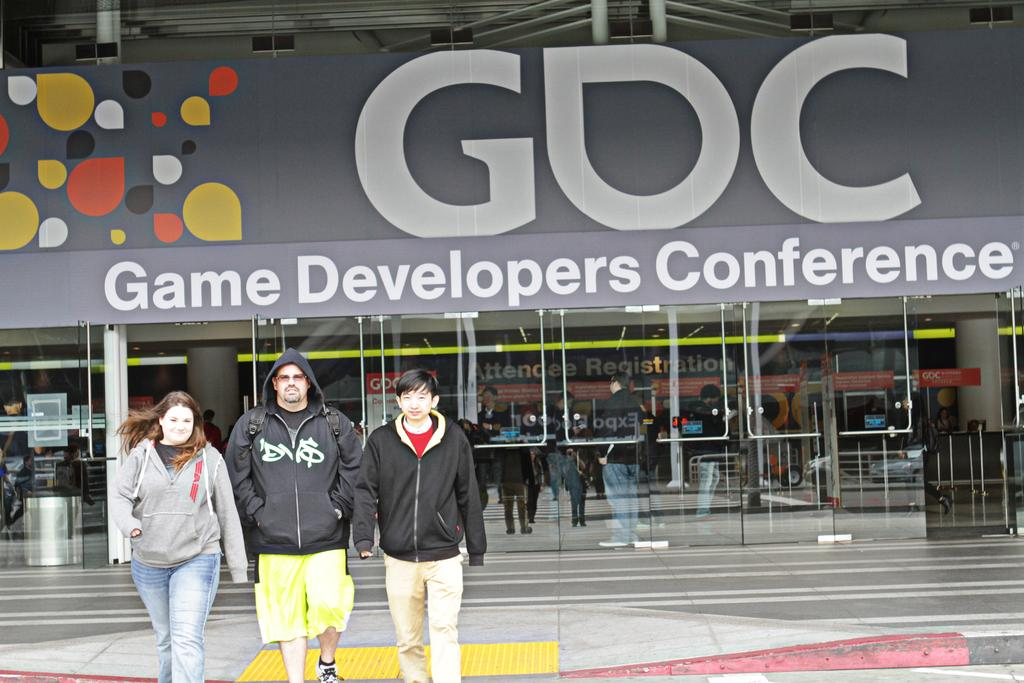What structure can be seen in the image? There is a building in the image. What are the people in the image doing? There are people walking in the image. Can you describe the appearance of one of the men in the image? A man is wearing sunglasses in the image. What is the name of the building in the image? There is a name board for the building in the image. What type of clothing can be seen on some of the men in the image? Some men are wearing jackets in the image. What type of surprise can be seen on the face of the man in the image? There is no indication of a surprise or any specific facial expression on the man in the image, as we cannot see his face clearly. What type of insurance is being advertised on the building in the image? There is no mention of insurance or any advertisement related to insurance on the building in the image. 